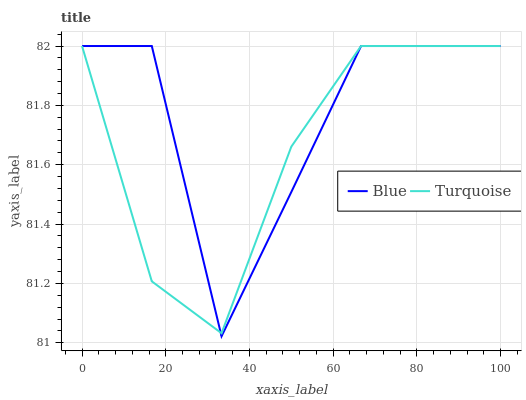Does Turquoise have the minimum area under the curve?
Answer yes or no. Yes. Does Blue have the maximum area under the curve?
Answer yes or no. Yes. Does Turquoise have the maximum area under the curve?
Answer yes or no. No. Is Turquoise the smoothest?
Answer yes or no. Yes. Is Blue the roughest?
Answer yes or no. Yes. Is Turquoise the roughest?
Answer yes or no. No. Does Blue have the lowest value?
Answer yes or no. Yes. Does Turquoise have the lowest value?
Answer yes or no. No. Does Turquoise have the highest value?
Answer yes or no. Yes. Does Turquoise intersect Blue?
Answer yes or no. Yes. Is Turquoise less than Blue?
Answer yes or no. No. Is Turquoise greater than Blue?
Answer yes or no. No. 